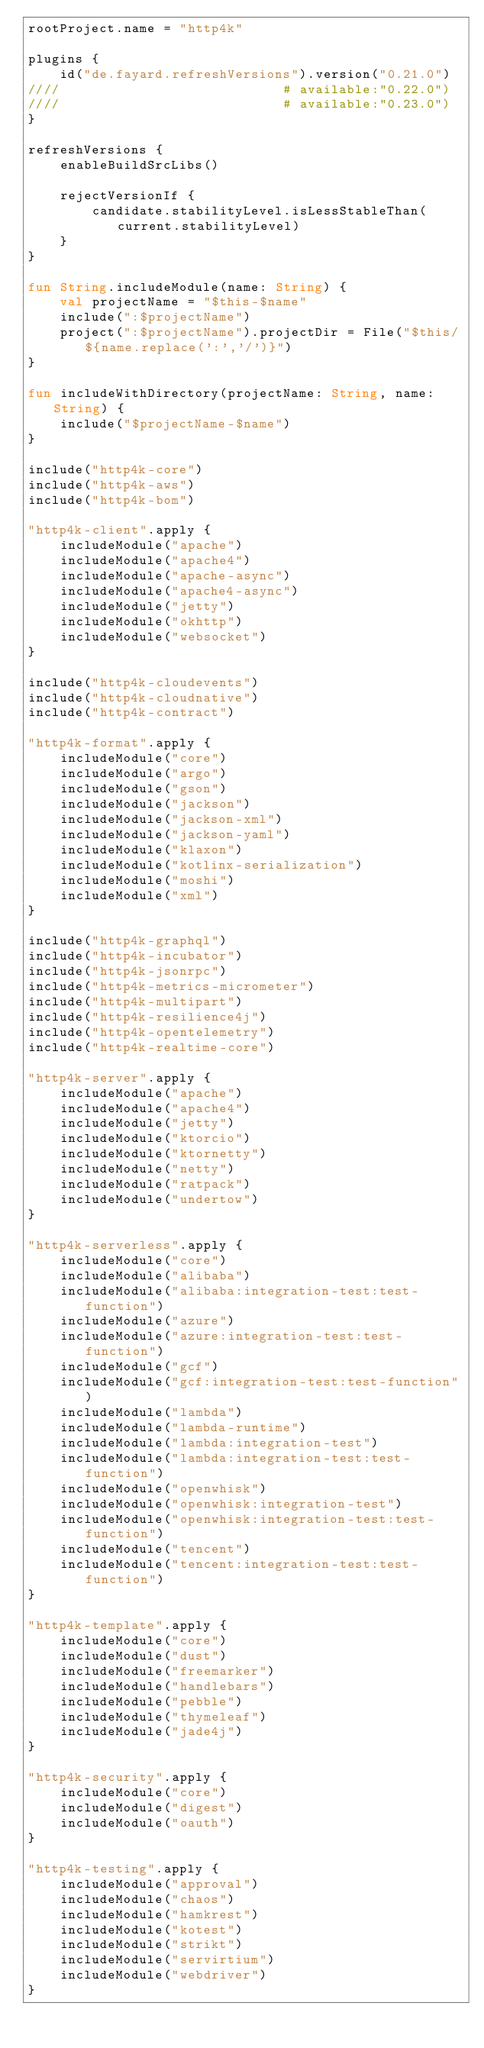<code> <loc_0><loc_0><loc_500><loc_500><_Kotlin_>rootProject.name = "http4k"

plugins {
    id("de.fayard.refreshVersions").version("0.21.0")
////                            # available:"0.22.0")
////                            # available:"0.23.0")
}

refreshVersions {
    enableBuildSrcLibs()

    rejectVersionIf {
        candidate.stabilityLevel.isLessStableThan(current.stabilityLevel)
    }
}

fun String.includeModule(name: String) {
    val projectName = "$this-$name"
    include(":$projectName")
    project(":$projectName").projectDir = File("$this/${name.replace(':','/')}")
}

fun includeWithDirectory(projectName: String, name: String) {
    include("$projectName-$name")
}

include("http4k-core")
include("http4k-aws")
include("http4k-bom")

"http4k-client".apply {
    includeModule("apache")
    includeModule("apache4")
    includeModule("apache-async")
    includeModule("apache4-async")
    includeModule("jetty")
    includeModule("okhttp")
    includeModule("websocket")
}

include("http4k-cloudevents")
include("http4k-cloudnative")
include("http4k-contract")

"http4k-format".apply {
    includeModule("core")
    includeModule("argo")
    includeModule("gson")
    includeModule("jackson")
    includeModule("jackson-xml")
    includeModule("jackson-yaml")
    includeModule("klaxon")
    includeModule("kotlinx-serialization")
    includeModule("moshi")
    includeModule("xml")
}

include("http4k-graphql")
include("http4k-incubator")
include("http4k-jsonrpc")
include("http4k-metrics-micrometer")
include("http4k-multipart")
include("http4k-resilience4j")
include("http4k-opentelemetry")
include("http4k-realtime-core")

"http4k-server".apply {
    includeModule("apache")
    includeModule("apache4")
    includeModule("jetty")
    includeModule("ktorcio")
    includeModule("ktornetty")
    includeModule("netty")
    includeModule("ratpack")
    includeModule("undertow")
}

"http4k-serverless".apply {
    includeModule("core")
    includeModule("alibaba")
    includeModule("alibaba:integration-test:test-function")
    includeModule("azure")
    includeModule("azure:integration-test:test-function")
    includeModule("gcf")
    includeModule("gcf:integration-test:test-function")
    includeModule("lambda")
    includeModule("lambda-runtime")
    includeModule("lambda:integration-test")
    includeModule("lambda:integration-test:test-function")
    includeModule("openwhisk")
    includeModule("openwhisk:integration-test")
    includeModule("openwhisk:integration-test:test-function")
    includeModule("tencent")
    includeModule("tencent:integration-test:test-function")
}

"http4k-template".apply {
    includeModule("core")
    includeModule("dust")
    includeModule("freemarker")
    includeModule("handlebars")
    includeModule("pebble")
    includeModule("thymeleaf")
    includeModule("jade4j")
}

"http4k-security".apply {
    includeModule("core")
    includeModule("digest")
    includeModule("oauth")
}

"http4k-testing".apply {
    includeModule("approval")
    includeModule("chaos")
    includeModule("hamkrest")
    includeModule("kotest")
    includeModule("strikt")
    includeModule("servirtium")
    includeModule("webdriver")
}
</code> 